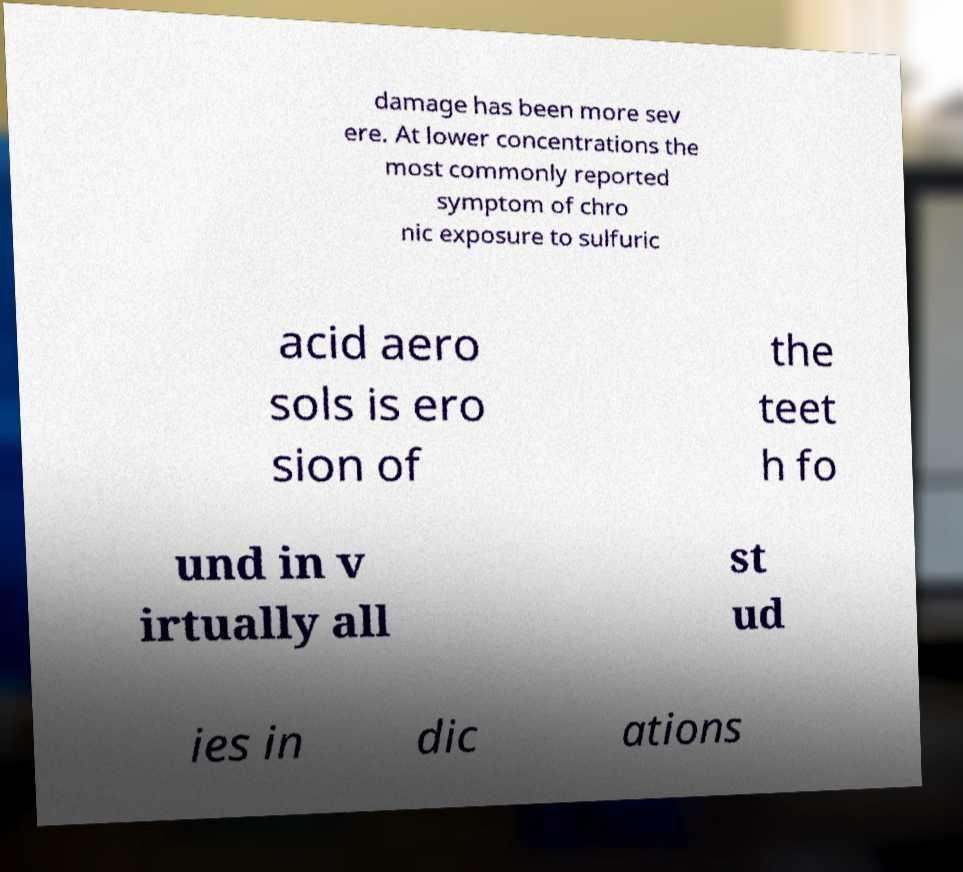Can you accurately transcribe the text from the provided image for me? damage has been more sev ere. At lower concentrations the most commonly reported symptom of chro nic exposure to sulfuric acid aero sols is ero sion of the teet h fo und in v irtually all st ud ies in dic ations 